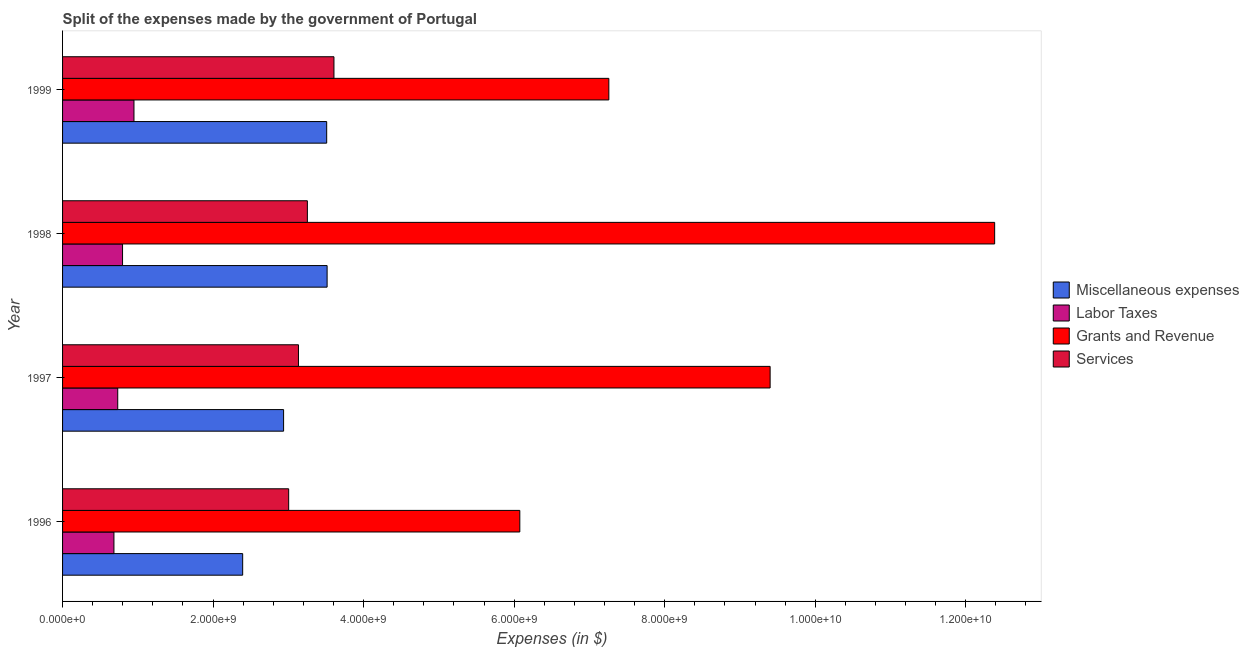How many different coloured bars are there?
Make the answer very short. 4. Are the number of bars on each tick of the Y-axis equal?
Your answer should be compact. Yes. How many bars are there on the 3rd tick from the top?
Provide a short and direct response. 4. What is the label of the 2nd group of bars from the top?
Keep it short and to the point. 1998. In how many cases, is the number of bars for a given year not equal to the number of legend labels?
Keep it short and to the point. 0. What is the amount spent on miscellaneous expenses in 1997?
Offer a very short reply. 2.94e+09. Across all years, what is the maximum amount spent on services?
Your answer should be compact. 3.61e+09. Across all years, what is the minimum amount spent on grants and revenue?
Give a very brief answer. 6.08e+09. In which year was the amount spent on miscellaneous expenses maximum?
Your response must be concise. 1998. What is the total amount spent on labor taxes in the graph?
Give a very brief answer. 3.16e+09. What is the difference between the amount spent on labor taxes in 1997 and that in 1999?
Offer a very short reply. -2.16e+08. What is the difference between the amount spent on labor taxes in 1999 and the amount spent on miscellaneous expenses in 1998?
Provide a short and direct response. -2.57e+09. What is the average amount spent on grants and revenue per year?
Your response must be concise. 8.78e+09. In the year 1998, what is the difference between the amount spent on miscellaneous expenses and amount spent on labor taxes?
Provide a succinct answer. 2.72e+09. In how many years, is the amount spent on labor taxes greater than 2000000000 $?
Ensure brevity in your answer.  0. What is the ratio of the amount spent on grants and revenue in 1998 to that in 1999?
Keep it short and to the point. 1.71. Is the amount spent on labor taxes in 1996 less than that in 1997?
Offer a terse response. Yes. What is the difference between the highest and the second highest amount spent on services?
Ensure brevity in your answer.  3.53e+08. What is the difference between the highest and the lowest amount spent on miscellaneous expenses?
Provide a succinct answer. 1.12e+09. In how many years, is the amount spent on services greater than the average amount spent on services taken over all years?
Ensure brevity in your answer.  2. Is it the case that in every year, the sum of the amount spent on labor taxes and amount spent on grants and revenue is greater than the sum of amount spent on miscellaneous expenses and amount spent on services?
Your response must be concise. Yes. What does the 2nd bar from the top in 1999 represents?
Your response must be concise. Grants and Revenue. What does the 4th bar from the bottom in 1999 represents?
Your answer should be very brief. Services. Is it the case that in every year, the sum of the amount spent on miscellaneous expenses and amount spent on labor taxes is greater than the amount spent on grants and revenue?
Your response must be concise. No. Are all the bars in the graph horizontal?
Keep it short and to the point. Yes. How many years are there in the graph?
Make the answer very short. 4. Does the graph contain grids?
Your answer should be very brief. No. Where does the legend appear in the graph?
Provide a succinct answer. Center right. How are the legend labels stacked?
Keep it short and to the point. Vertical. What is the title of the graph?
Make the answer very short. Split of the expenses made by the government of Portugal. Does "Periodicity assessment" appear as one of the legend labels in the graph?
Provide a short and direct response. No. What is the label or title of the X-axis?
Your answer should be compact. Expenses (in $). What is the label or title of the Y-axis?
Your answer should be compact. Year. What is the Expenses (in $) in Miscellaneous expenses in 1996?
Your answer should be compact. 2.39e+09. What is the Expenses (in $) of Labor Taxes in 1996?
Give a very brief answer. 6.82e+08. What is the Expenses (in $) in Grants and Revenue in 1996?
Keep it short and to the point. 6.08e+09. What is the Expenses (in $) of Services in 1996?
Make the answer very short. 3.00e+09. What is the Expenses (in $) in Miscellaneous expenses in 1997?
Offer a terse response. 2.94e+09. What is the Expenses (in $) in Labor Taxes in 1997?
Provide a succinct answer. 7.33e+08. What is the Expenses (in $) of Grants and Revenue in 1997?
Offer a terse response. 9.40e+09. What is the Expenses (in $) of Services in 1997?
Offer a terse response. 3.13e+09. What is the Expenses (in $) in Miscellaneous expenses in 1998?
Keep it short and to the point. 3.51e+09. What is the Expenses (in $) of Labor Taxes in 1998?
Make the answer very short. 7.97e+08. What is the Expenses (in $) in Grants and Revenue in 1998?
Provide a short and direct response. 1.24e+1. What is the Expenses (in $) in Services in 1998?
Offer a terse response. 3.25e+09. What is the Expenses (in $) of Miscellaneous expenses in 1999?
Offer a terse response. 3.51e+09. What is the Expenses (in $) in Labor Taxes in 1999?
Your answer should be very brief. 9.49e+08. What is the Expenses (in $) of Grants and Revenue in 1999?
Offer a terse response. 7.26e+09. What is the Expenses (in $) in Services in 1999?
Your answer should be compact. 3.61e+09. Across all years, what is the maximum Expenses (in $) in Miscellaneous expenses?
Provide a short and direct response. 3.51e+09. Across all years, what is the maximum Expenses (in $) of Labor Taxes?
Ensure brevity in your answer.  9.49e+08. Across all years, what is the maximum Expenses (in $) of Grants and Revenue?
Offer a very short reply. 1.24e+1. Across all years, what is the maximum Expenses (in $) of Services?
Make the answer very short. 3.61e+09. Across all years, what is the minimum Expenses (in $) of Miscellaneous expenses?
Offer a terse response. 2.39e+09. Across all years, what is the minimum Expenses (in $) in Labor Taxes?
Provide a short and direct response. 6.82e+08. Across all years, what is the minimum Expenses (in $) in Grants and Revenue?
Your answer should be compact. 6.08e+09. Across all years, what is the minimum Expenses (in $) in Services?
Offer a very short reply. 3.00e+09. What is the total Expenses (in $) in Miscellaneous expenses in the graph?
Give a very brief answer. 1.24e+1. What is the total Expenses (in $) of Labor Taxes in the graph?
Your response must be concise. 3.16e+09. What is the total Expenses (in $) in Grants and Revenue in the graph?
Provide a succinct answer. 3.51e+1. What is the total Expenses (in $) of Services in the graph?
Offer a terse response. 1.30e+1. What is the difference between the Expenses (in $) of Miscellaneous expenses in 1996 and that in 1997?
Your response must be concise. -5.44e+08. What is the difference between the Expenses (in $) in Labor Taxes in 1996 and that in 1997?
Keep it short and to the point. -5.06e+07. What is the difference between the Expenses (in $) in Grants and Revenue in 1996 and that in 1997?
Your answer should be very brief. -3.33e+09. What is the difference between the Expenses (in $) of Services in 1996 and that in 1997?
Provide a succinct answer. -1.30e+08. What is the difference between the Expenses (in $) in Miscellaneous expenses in 1996 and that in 1998?
Provide a succinct answer. -1.12e+09. What is the difference between the Expenses (in $) in Labor Taxes in 1996 and that in 1998?
Provide a succinct answer. -1.14e+08. What is the difference between the Expenses (in $) of Grants and Revenue in 1996 and that in 1998?
Give a very brief answer. -6.31e+09. What is the difference between the Expenses (in $) of Services in 1996 and that in 1998?
Your answer should be very brief. -2.48e+08. What is the difference between the Expenses (in $) in Miscellaneous expenses in 1996 and that in 1999?
Your answer should be compact. -1.12e+09. What is the difference between the Expenses (in $) of Labor Taxes in 1996 and that in 1999?
Make the answer very short. -2.66e+08. What is the difference between the Expenses (in $) of Grants and Revenue in 1996 and that in 1999?
Your response must be concise. -1.18e+09. What is the difference between the Expenses (in $) of Services in 1996 and that in 1999?
Offer a very short reply. -6.02e+08. What is the difference between the Expenses (in $) in Miscellaneous expenses in 1997 and that in 1998?
Make the answer very short. -5.78e+08. What is the difference between the Expenses (in $) of Labor Taxes in 1997 and that in 1998?
Your response must be concise. -6.38e+07. What is the difference between the Expenses (in $) in Grants and Revenue in 1997 and that in 1998?
Keep it short and to the point. -2.98e+09. What is the difference between the Expenses (in $) of Services in 1997 and that in 1998?
Offer a terse response. -1.18e+08. What is the difference between the Expenses (in $) of Miscellaneous expenses in 1997 and that in 1999?
Your response must be concise. -5.73e+08. What is the difference between the Expenses (in $) in Labor Taxes in 1997 and that in 1999?
Your answer should be compact. -2.16e+08. What is the difference between the Expenses (in $) of Grants and Revenue in 1997 and that in 1999?
Give a very brief answer. 2.14e+09. What is the difference between the Expenses (in $) in Services in 1997 and that in 1999?
Keep it short and to the point. -4.71e+08. What is the difference between the Expenses (in $) of Miscellaneous expenses in 1998 and that in 1999?
Provide a short and direct response. 5.61e+06. What is the difference between the Expenses (in $) in Labor Taxes in 1998 and that in 1999?
Keep it short and to the point. -1.52e+08. What is the difference between the Expenses (in $) of Grants and Revenue in 1998 and that in 1999?
Give a very brief answer. 5.13e+09. What is the difference between the Expenses (in $) of Services in 1998 and that in 1999?
Ensure brevity in your answer.  -3.53e+08. What is the difference between the Expenses (in $) in Miscellaneous expenses in 1996 and the Expenses (in $) in Labor Taxes in 1997?
Keep it short and to the point. 1.66e+09. What is the difference between the Expenses (in $) of Miscellaneous expenses in 1996 and the Expenses (in $) of Grants and Revenue in 1997?
Your answer should be very brief. -7.01e+09. What is the difference between the Expenses (in $) of Miscellaneous expenses in 1996 and the Expenses (in $) of Services in 1997?
Provide a short and direct response. -7.41e+08. What is the difference between the Expenses (in $) in Labor Taxes in 1996 and the Expenses (in $) in Grants and Revenue in 1997?
Your response must be concise. -8.72e+09. What is the difference between the Expenses (in $) in Labor Taxes in 1996 and the Expenses (in $) in Services in 1997?
Offer a very short reply. -2.45e+09. What is the difference between the Expenses (in $) of Grants and Revenue in 1996 and the Expenses (in $) of Services in 1997?
Provide a short and direct response. 2.94e+09. What is the difference between the Expenses (in $) of Miscellaneous expenses in 1996 and the Expenses (in $) of Labor Taxes in 1998?
Provide a short and direct response. 1.60e+09. What is the difference between the Expenses (in $) in Miscellaneous expenses in 1996 and the Expenses (in $) in Grants and Revenue in 1998?
Your answer should be very brief. -9.99e+09. What is the difference between the Expenses (in $) in Miscellaneous expenses in 1996 and the Expenses (in $) in Services in 1998?
Your answer should be very brief. -8.60e+08. What is the difference between the Expenses (in $) of Labor Taxes in 1996 and the Expenses (in $) of Grants and Revenue in 1998?
Your response must be concise. -1.17e+1. What is the difference between the Expenses (in $) of Labor Taxes in 1996 and the Expenses (in $) of Services in 1998?
Your answer should be very brief. -2.57e+09. What is the difference between the Expenses (in $) in Grants and Revenue in 1996 and the Expenses (in $) in Services in 1998?
Keep it short and to the point. 2.82e+09. What is the difference between the Expenses (in $) in Miscellaneous expenses in 1996 and the Expenses (in $) in Labor Taxes in 1999?
Your answer should be very brief. 1.44e+09. What is the difference between the Expenses (in $) in Miscellaneous expenses in 1996 and the Expenses (in $) in Grants and Revenue in 1999?
Provide a short and direct response. -4.87e+09. What is the difference between the Expenses (in $) of Miscellaneous expenses in 1996 and the Expenses (in $) of Services in 1999?
Ensure brevity in your answer.  -1.21e+09. What is the difference between the Expenses (in $) in Labor Taxes in 1996 and the Expenses (in $) in Grants and Revenue in 1999?
Offer a terse response. -6.58e+09. What is the difference between the Expenses (in $) of Labor Taxes in 1996 and the Expenses (in $) of Services in 1999?
Keep it short and to the point. -2.92e+09. What is the difference between the Expenses (in $) of Grants and Revenue in 1996 and the Expenses (in $) of Services in 1999?
Your response must be concise. 2.47e+09. What is the difference between the Expenses (in $) of Miscellaneous expenses in 1997 and the Expenses (in $) of Labor Taxes in 1998?
Make the answer very short. 2.14e+09. What is the difference between the Expenses (in $) in Miscellaneous expenses in 1997 and the Expenses (in $) in Grants and Revenue in 1998?
Provide a succinct answer. -9.45e+09. What is the difference between the Expenses (in $) of Miscellaneous expenses in 1997 and the Expenses (in $) of Services in 1998?
Keep it short and to the point. -3.16e+08. What is the difference between the Expenses (in $) of Labor Taxes in 1997 and the Expenses (in $) of Grants and Revenue in 1998?
Make the answer very short. -1.17e+1. What is the difference between the Expenses (in $) in Labor Taxes in 1997 and the Expenses (in $) in Services in 1998?
Your answer should be compact. -2.52e+09. What is the difference between the Expenses (in $) of Grants and Revenue in 1997 and the Expenses (in $) of Services in 1998?
Provide a short and direct response. 6.15e+09. What is the difference between the Expenses (in $) in Miscellaneous expenses in 1997 and the Expenses (in $) in Labor Taxes in 1999?
Offer a very short reply. 1.99e+09. What is the difference between the Expenses (in $) of Miscellaneous expenses in 1997 and the Expenses (in $) of Grants and Revenue in 1999?
Provide a short and direct response. -4.32e+09. What is the difference between the Expenses (in $) in Miscellaneous expenses in 1997 and the Expenses (in $) in Services in 1999?
Your response must be concise. -6.69e+08. What is the difference between the Expenses (in $) in Labor Taxes in 1997 and the Expenses (in $) in Grants and Revenue in 1999?
Offer a very short reply. -6.53e+09. What is the difference between the Expenses (in $) in Labor Taxes in 1997 and the Expenses (in $) in Services in 1999?
Offer a terse response. -2.87e+09. What is the difference between the Expenses (in $) in Grants and Revenue in 1997 and the Expenses (in $) in Services in 1999?
Offer a terse response. 5.80e+09. What is the difference between the Expenses (in $) in Miscellaneous expenses in 1998 and the Expenses (in $) in Labor Taxes in 1999?
Give a very brief answer. 2.57e+09. What is the difference between the Expenses (in $) of Miscellaneous expenses in 1998 and the Expenses (in $) of Grants and Revenue in 1999?
Give a very brief answer. -3.74e+09. What is the difference between the Expenses (in $) in Miscellaneous expenses in 1998 and the Expenses (in $) in Services in 1999?
Offer a very short reply. -9.09e+07. What is the difference between the Expenses (in $) of Labor Taxes in 1998 and the Expenses (in $) of Grants and Revenue in 1999?
Keep it short and to the point. -6.46e+09. What is the difference between the Expenses (in $) of Labor Taxes in 1998 and the Expenses (in $) of Services in 1999?
Provide a succinct answer. -2.81e+09. What is the difference between the Expenses (in $) in Grants and Revenue in 1998 and the Expenses (in $) in Services in 1999?
Offer a very short reply. 8.78e+09. What is the average Expenses (in $) in Miscellaneous expenses per year?
Provide a succinct answer. 3.09e+09. What is the average Expenses (in $) of Labor Taxes per year?
Your answer should be very brief. 7.90e+08. What is the average Expenses (in $) of Grants and Revenue per year?
Your answer should be very brief. 8.78e+09. What is the average Expenses (in $) in Services per year?
Give a very brief answer. 3.25e+09. In the year 1996, what is the difference between the Expenses (in $) in Miscellaneous expenses and Expenses (in $) in Labor Taxes?
Provide a succinct answer. 1.71e+09. In the year 1996, what is the difference between the Expenses (in $) in Miscellaneous expenses and Expenses (in $) in Grants and Revenue?
Provide a succinct answer. -3.68e+09. In the year 1996, what is the difference between the Expenses (in $) in Miscellaneous expenses and Expenses (in $) in Services?
Give a very brief answer. -6.11e+08. In the year 1996, what is the difference between the Expenses (in $) of Labor Taxes and Expenses (in $) of Grants and Revenue?
Keep it short and to the point. -5.39e+09. In the year 1996, what is the difference between the Expenses (in $) in Labor Taxes and Expenses (in $) in Services?
Make the answer very short. -2.32e+09. In the year 1996, what is the difference between the Expenses (in $) of Grants and Revenue and Expenses (in $) of Services?
Your response must be concise. 3.07e+09. In the year 1997, what is the difference between the Expenses (in $) of Miscellaneous expenses and Expenses (in $) of Labor Taxes?
Your answer should be compact. 2.20e+09. In the year 1997, what is the difference between the Expenses (in $) of Miscellaneous expenses and Expenses (in $) of Grants and Revenue?
Make the answer very short. -6.46e+09. In the year 1997, what is the difference between the Expenses (in $) of Miscellaneous expenses and Expenses (in $) of Services?
Your response must be concise. -1.98e+08. In the year 1997, what is the difference between the Expenses (in $) in Labor Taxes and Expenses (in $) in Grants and Revenue?
Offer a terse response. -8.67e+09. In the year 1997, what is the difference between the Expenses (in $) of Labor Taxes and Expenses (in $) of Services?
Provide a short and direct response. -2.40e+09. In the year 1997, what is the difference between the Expenses (in $) of Grants and Revenue and Expenses (in $) of Services?
Make the answer very short. 6.27e+09. In the year 1998, what is the difference between the Expenses (in $) of Miscellaneous expenses and Expenses (in $) of Labor Taxes?
Provide a short and direct response. 2.72e+09. In the year 1998, what is the difference between the Expenses (in $) of Miscellaneous expenses and Expenses (in $) of Grants and Revenue?
Give a very brief answer. -8.87e+09. In the year 1998, what is the difference between the Expenses (in $) in Miscellaneous expenses and Expenses (in $) in Services?
Make the answer very short. 2.62e+08. In the year 1998, what is the difference between the Expenses (in $) of Labor Taxes and Expenses (in $) of Grants and Revenue?
Your answer should be very brief. -1.16e+1. In the year 1998, what is the difference between the Expenses (in $) of Labor Taxes and Expenses (in $) of Services?
Keep it short and to the point. -2.46e+09. In the year 1998, what is the difference between the Expenses (in $) in Grants and Revenue and Expenses (in $) in Services?
Offer a very short reply. 9.13e+09. In the year 1999, what is the difference between the Expenses (in $) of Miscellaneous expenses and Expenses (in $) of Labor Taxes?
Keep it short and to the point. 2.56e+09. In the year 1999, what is the difference between the Expenses (in $) in Miscellaneous expenses and Expenses (in $) in Grants and Revenue?
Your response must be concise. -3.75e+09. In the year 1999, what is the difference between the Expenses (in $) in Miscellaneous expenses and Expenses (in $) in Services?
Ensure brevity in your answer.  -9.65e+07. In the year 1999, what is the difference between the Expenses (in $) in Labor Taxes and Expenses (in $) in Grants and Revenue?
Offer a terse response. -6.31e+09. In the year 1999, what is the difference between the Expenses (in $) of Labor Taxes and Expenses (in $) of Services?
Provide a short and direct response. -2.66e+09. In the year 1999, what is the difference between the Expenses (in $) in Grants and Revenue and Expenses (in $) in Services?
Offer a very short reply. 3.65e+09. What is the ratio of the Expenses (in $) in Miscellaneous expenses in 1996 to that in 1997?
Make the answer very short. 0.81. What is the ratio of the Expenses (in $) in Grants and Revenue in 1996 to that in 1997?
Offer a very short reply. 0.65. What is the ratio of the Expenses (in $) of Services in 1996 to that in 1997?
Your answer should be compact. 0.96. What is the ratio of the Expenses (in $) in Miscellaneous expenses in 1996 to that in 1998?
Provide a short and direct response. 0.68. What is the ratio of the Expenses (in $) of Labor Taxes in 1996 to that in 1998?
Your response must be concise. 0.86. What is the ratio of the Expenses (in $) of Grants and Revenue in 1996 to that in 1998?
Offer a terse response. 0.49. What is the ratio of the Expenses (in $) of Services in 1996 to that in 1998?
Your answer should be very brief. 0.92. What is the ratio of the Expenses (in $) of Miscellaneous expenses in 1996 to that in 1999?
Your response must be concise. 0.68. What is the ratio of the Expenses (in $) of Labor Taxes in 1996 to that in 1999?
Your answer should be very brief. 0.72. What is the ratio of the Expenses (in $) of Grants and Revenue in 1996 to that in 1999?
Give a very brief answer. 0.84. What is the ratio of the Expenses (in $) of Services in 1996 to that in 1999?
Keep it short and to the point. 0.83. What is the ratio of the Expenses (in $) of Miscellaneous expenses in 1997 to that in 1998?
Provide a short and direct response. 0.84. What is the ratio of the Expenses (in $) of Labor Taxes in 1997 to that in 1998?
Ensure brevity in your answer.  0.92. What is the ratio of the Expenses (in $) in Grants and Revenue in 1997 to that in 1998?
Make the answer very short. 0.76. What is the ratio of the Expenses (in $) in Services in 1997 to that in 1998?
Your response must be concise. 0.96. What is the ratio of the Expenses (in $) of Miscellaneous expenses in 1997 to that in 1999?
Make the answer very short. 0.84. What is the ratio of the Expenses (in $) of Labor Taxes in 1997 to that in 1999?
Give a very brief answer. 0.77. What is the ratio of the Expenses (in $) in Grants and Revenue in 1997 to that in 1999?
Your answer should be compact. 1.3. What is the ratio of the Expenses (in $) of Services in 1997 to that in 1999?
Provide a succinct answer. 0.87. What is the ratio of the Expenses (in $) in Labor Taxes in 1998 to that in 1999?
Make the answer very short. 0.84. What is the ratio of the Expenses (in $) in Grants and Revenue in 1998 to that in 1999?
Your response must be concise. 1.71. What is the ratio of the Expenses (in $) of Services in 1998 to that in 1999?
Make the answer very short. 0.9. What is the difference between the highest and the second highest Expenses (in $) of Miscellaneous expenses?
Your answer should be very brief. 5.61e+06. What is the difference between the highest and the second highest Expenses (in $) of Labor Taxes?
Provide a short and direct response. 1.52e+08. What is the difference between the highest and the second highest Expenses (in $) of Grants and Revenue?
Offer a terse response. 2.98e+09. What is the difference between the highest and the second highest Expenses (in $) of Services?
Ensure brevity in your answer.  3.53e+08. What is the difference between the highest and the lowest Expenses (in $) in Miscellaneous expenses?
Provide a short and direct response. 1.12e+09. What is the difference between the highest and the lowest Expenses (in $) in Labor Taxes?
Your response must be concise. 2.66e+08. What is the difference between the highest and the lowest Expenses (in $) of Grants and Revenue?
Provide a succinct answer. 6.31e+09. What is the difference between the highest and the lowest Expenses (in $) of Services?
Your answer should be compact. 6.02e+08. 